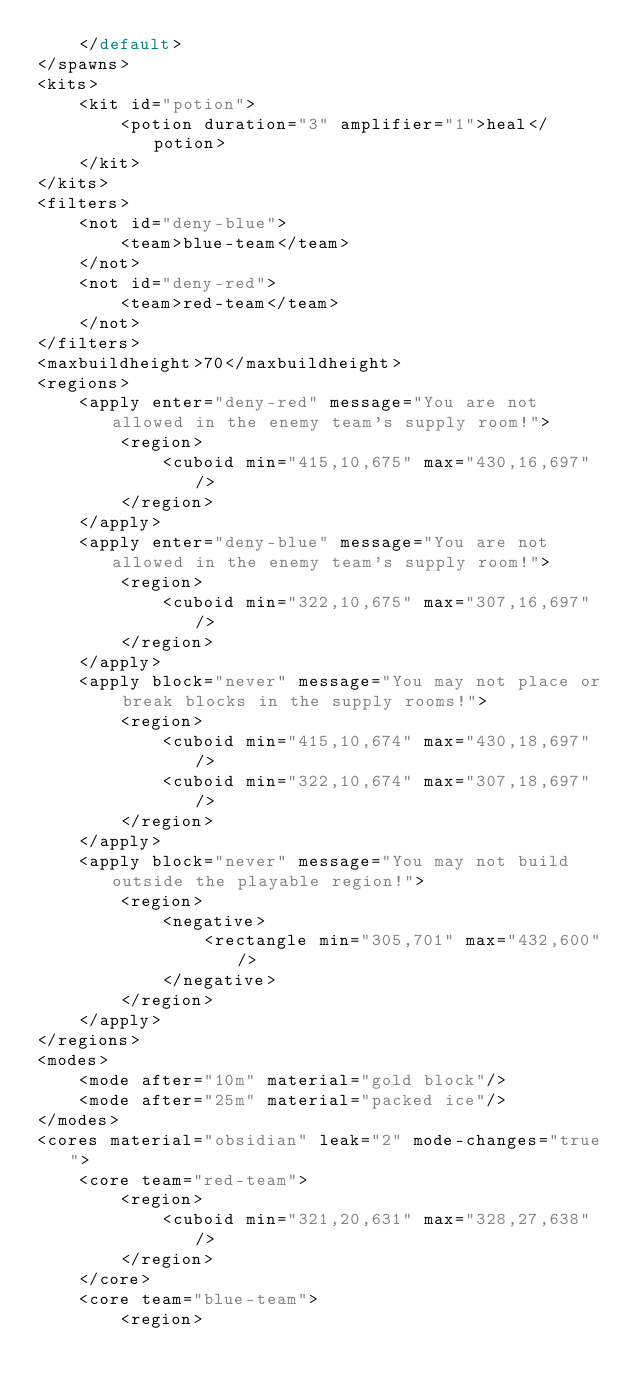<code> <loc_0><loc_0><loc_500><loc_500><_XML_>    </default>
</spawns>
<kits>
    <kit id="potion">
        <potion duration="3" amplifier="1">heal</potion>
    </kit>
</kits>
<filters>
    <not id="deny-blue">
        <team>blue-team</team>
    </not>
    <not id="deny-red">
        <team>red-team</team>
    </not>
</filters>
<maxbuildheight>70</maxbuildheight>
<regions>
    <apply enter="deny-red" message="You are not allowed in the enemy team's supply room!">
        <region>
            <cuboid min="415,10,675" max="430,16,697"/>
        </region>
    </apply>
    <apply enter="deny-blue" message="You are not allowed in the enemy team's supply room!">
        <region>
            <cuboid min="322,10,675" max="307,16,697"/>
        </region>
    </apply>
    <apply block="never" message="You may not place or break blocks in the supply rooms!">
        <region>
            <cuboid min="415,10,674" max="430,18,697"/>
            <cuboid min="322,10,674" max="307,18,697"/>
        </region>
    </apply>
    <apply block="never" message="You may not build outside the playable region!">
        <region>
            <negative>
                <rectangle min="305,701" max="432,600"/>
            </negative>
        </region>
    </apply>
</regions>
<modes>
    <mode after="10m" material="gold block"/>
    <mode after="25m" material="packed ice"/>
</modes>
<cores material="obsidian" leak="2" mode-changes="true">
    <core team="red-team">
        <region>
            <cuboid min="321,20,631" max="328,27,638"/>
        </region>
    </core>
    <core team="blue-team">
        <region></code> 